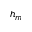<formula> <loc_0><loc_0><loc_500><loc_500>h _ { m }</formula> 